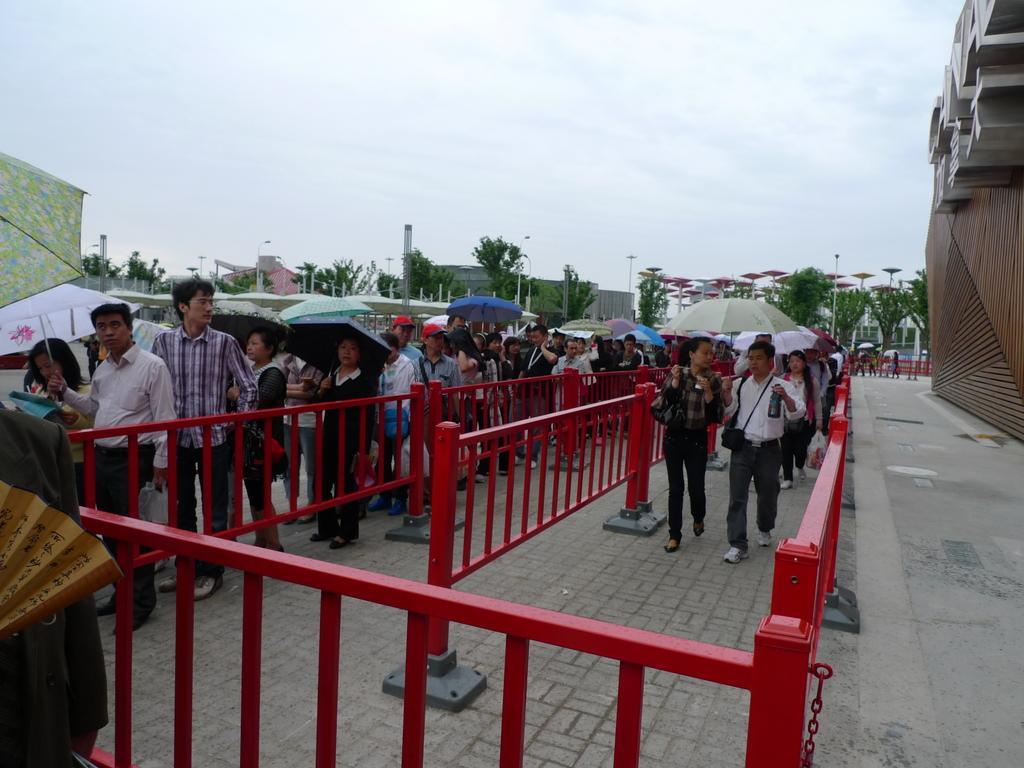Can you describe this image briefly? This image is taken outdoors. At the top of the image there is the sky with clouds. In the background there are many trees. There are many poles with street lights and there are a few objects and there is a house. On the right side of the image there is an architecture and there is a road. In the middle of the image there are a few things and many people are walking on the road. They are holding umbrellas in their hands. 